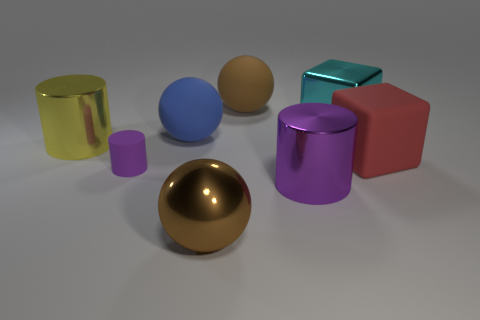Is the number of large blue matte balls that are behind the big blue thing the same as the number of big cyan rubber objects? While there appears to be one large blue matte ball behind the big blue object, there are no cyan objects, rubber or otherwise, to compare it with. It's important to closely examine the colors and materials in the image to make accurate comparisons. 